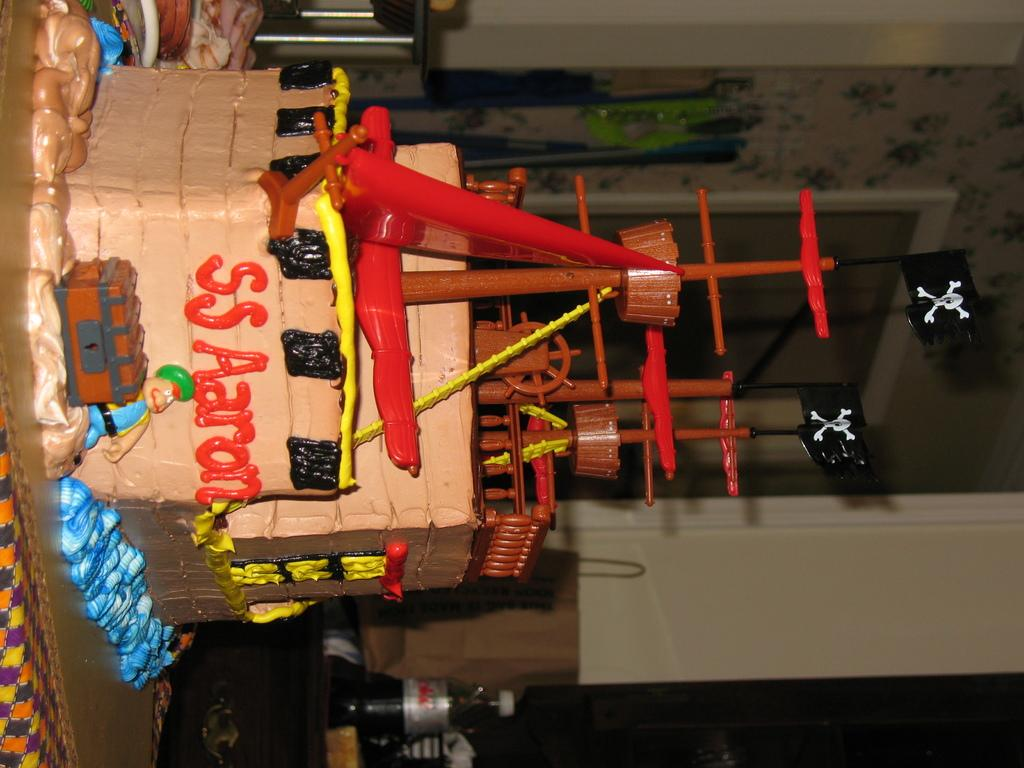What is the main object on the table in the image? There is a cake on the table. What beverage is visible in the image? There is a coke bottle on the side. What type of material is covering the table? There is cloth on the table. How many nails are used to hold the paper in place in the image? There is no paper or nails present in the image. 